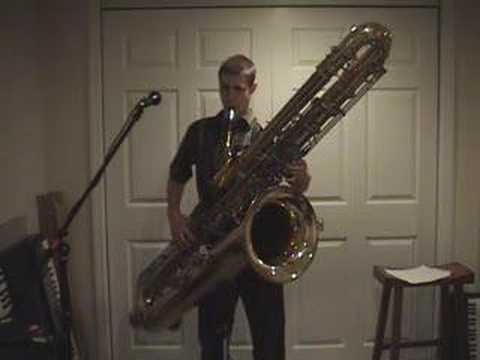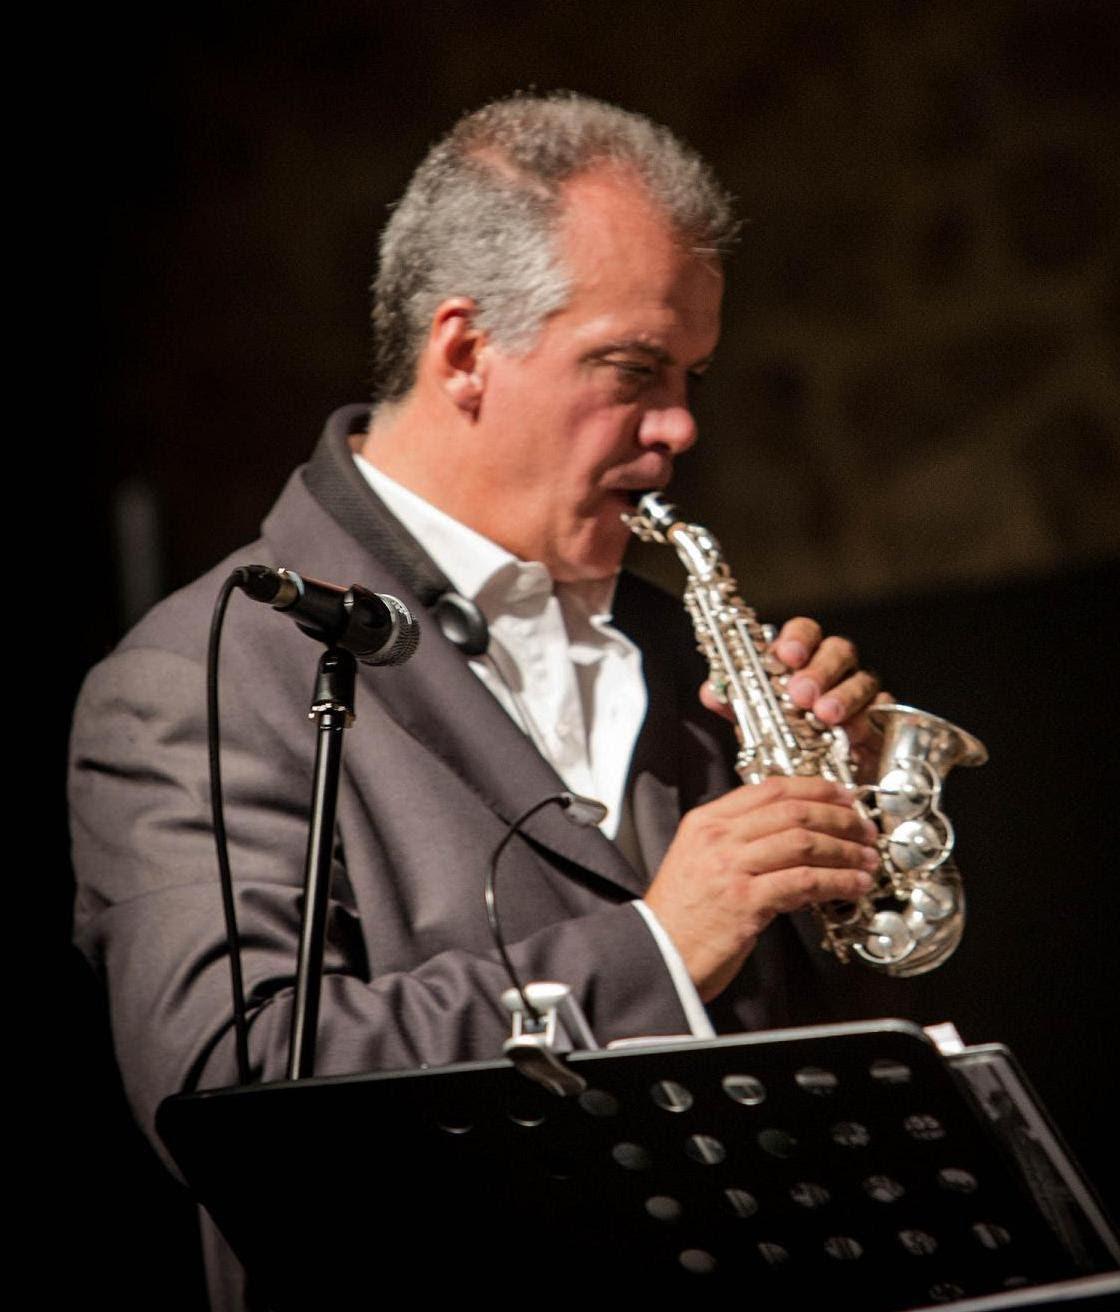The first image is the image on the left, the second image is the image on the right. Examine the images to the left and right. Is the description "In at least one  image there is a young man with a supersized saxophone tilted right and strapped to him while he is playing it." accurate? Answer yes or no. Yes. The first image is the image on the left, the second image is the image on the right. Examine the images to the left and right. Is the description "Each image shows a man with an oversized gold saxophone, and in at least one image, the saxophone is on a black stand." accurate? Answer yes or no. No. 